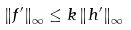<formula> <loc_0><loc_0><loc_500><loc_500>\left \| f ^ { \prime } \right \| _ { \infty } \leq k \left \| h ^ { \prime } \right \| _ { \infty }</formula> 